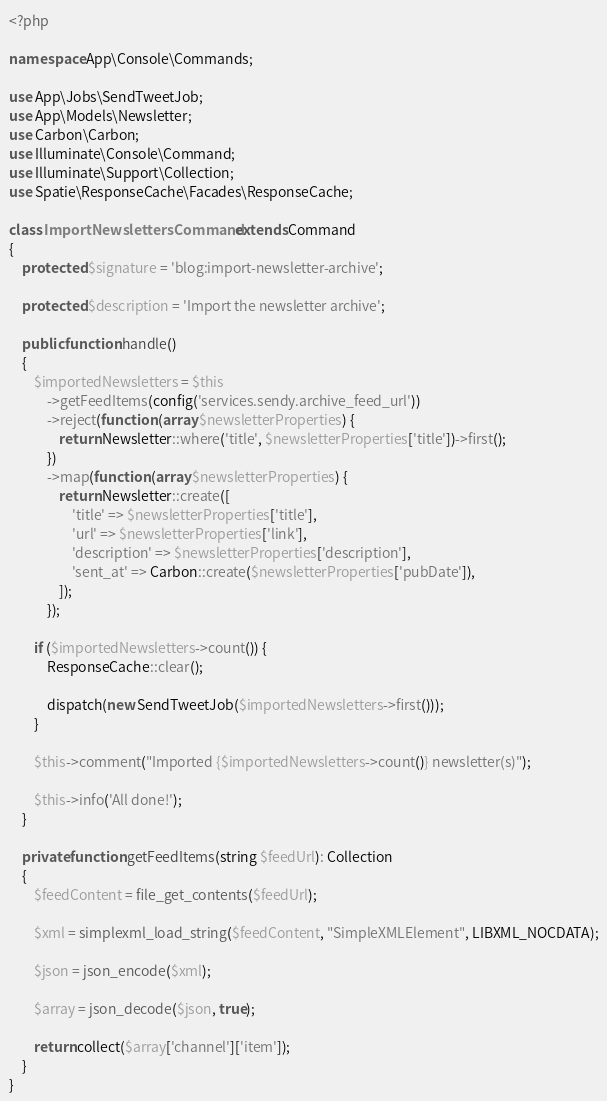<code> <loc_0><loc_0><loc_500><loc_500><_PHP_><?php

namespace App\Console\Commands;

use App\Jobs\SendTweetJob;
use App\Models\Newsletter;
use Carbon\Carbon;
use Illuminate\Console\Command;
use Illuminate\Support\Collection;
use Spatie\ResponseCache\Facades\ResponseCache;

class ImportNewslettersCommand extends Command
{
    protected $signature = 'blog:import-newsletter-archive';

    protected $description = 'Import the newsletter archive';

    public function handle()
    {
        $importedNewsletters = $this
            ->getFeedItems(config('services.sendy.archive_feed_url'))
            ->reject(function (array $newsletterProperties) {
                return Newsletter::where('title', $newsletterProperties['title'])->first();
            })
            ->map(function (array $newsletterProperties) {
                return Newsletter::create([
                    'title' => $newsletterProperties['title'],
                    'url' => $newsletterProperties['link'],
                    'description' => $newsletterProperties['description'],
                    'sent_at' => Carbon::create($newsletterProperties['pubDate']),
                ]);
            });

        if ($importedNewsletters->count()) {
            ResponseCache::clear();

            dispatch(new SendTweetJob($importedNewsletters->first()));
        }

        $this->comment("Imported {$importedNewsletters->count()} newsletter(s)");

        $this->info('All done!');
    }

    private function getFeedItems(string $feedUrl): Collection
    {
        $feedContent = file_get_contents($feedUrl);

        $xml = simplexml_load_string($feedContent, "SimpleXMLElement", LIBXML_NOCDATA);

        $json = json_encode($xml);

        $array = json_decode($json, true);

        return collect($array['channel']['item']);
    }
}
</code> 